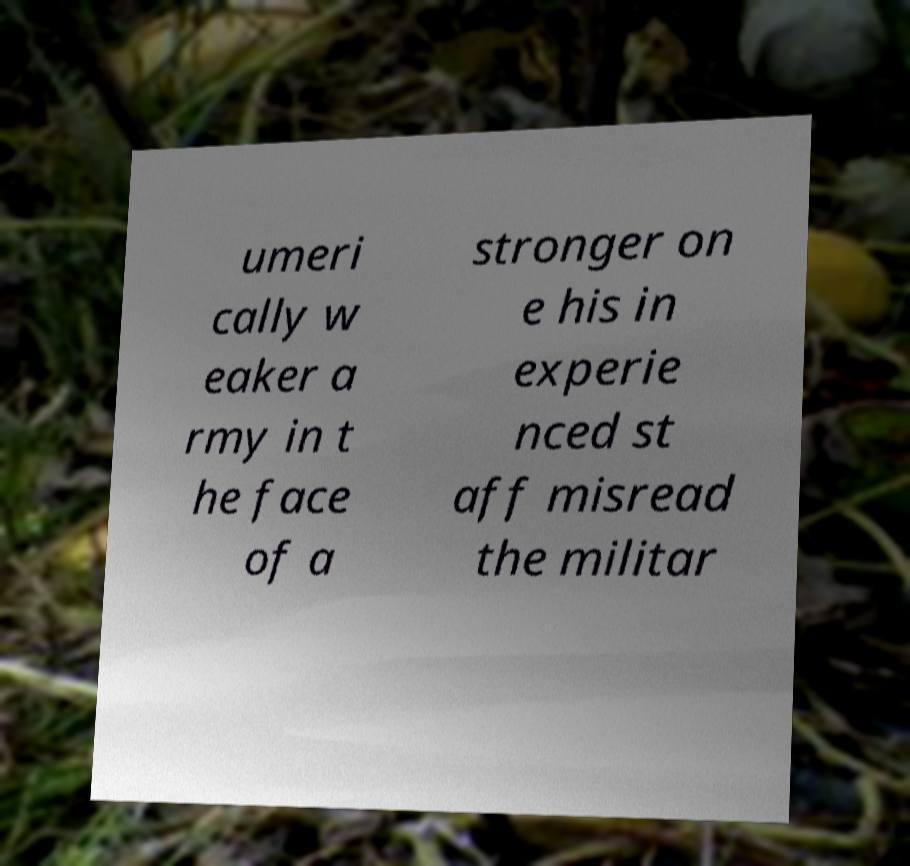Please identify and transcribe the text found in this image. umeri cally w eaker a rmy in t he face of a stronger on e his in experie nced st aff misread the militar 